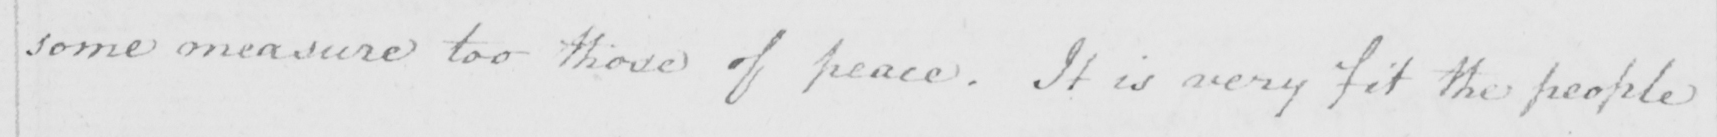What text is written in this handwritten line? some measure too those of peace . It is very fit the people 